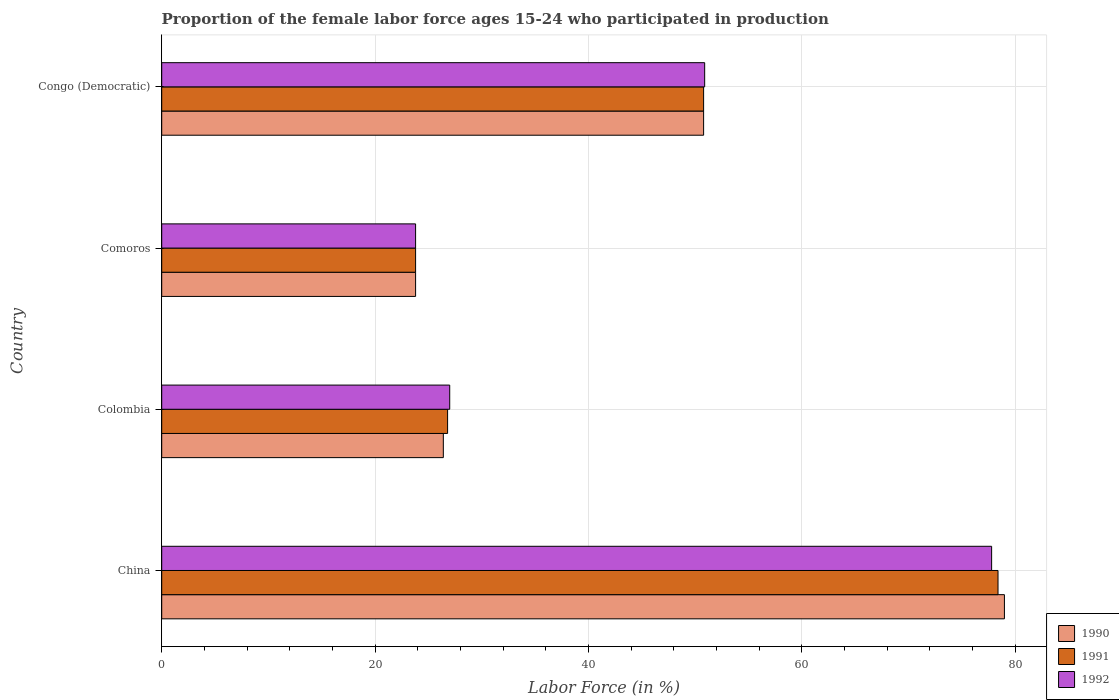Are the number of bars on each tick of the Y-axis equal?
Your answer should be very brief. Yes. How many bars are there on the 3rd tick from the bottom?
Provide a succinct answer. 3. What is the label of the 3rd group of bars from the top?
Provide a succinct answer. Colombia. In how many cases, is the number of bars for a given country not equal to the number of legend labels?
Offer a terse response. 0. What is the proportion of the female labor force who participated in production in 1991 in Congo (Democratic)?
Keep it short and to the point. 50.8. Across all countries, what is the maximum proportion of the female labor force who participated in production in 1991?
Ensure brevity in your answer.  78.4. Across all countries, what is the minimum proportion of the female labor force who participated in production in 1991?
Ensure brevity in your answer.  23.8. In which country was the proportion of the female labor force who participated in production in 1990 maximum?
Offer a very short reply. China. In which country was the proportion of the female labor force who participated in production in 1992 minimum?
Offer a terse response. Comoros. What is the total proportion of the female labor force who participated in production in 1990 in the graph?
Keep it short and to the point. 180. What is the difference between the proportion of the female labor force who participated in production in 1991 in Colombia and that in Congo (Democratic)?
Ensure brevity in your answer.  -24. What is the difference between the proportion of the female labor force who participated in production in 1992 in Comoros and the proportion of the female labor force who participated in production in 1990 in China?
Make the answer very short. -55.2. What is the average proportion of the female labor force who participated in production in 1990 per country?
Offer a terse response. 45. What is the difference between the proportion of the female labor force who participated in production in 1992 and proportion of the female labor force who participated in production in 1991 in Colombia?
Keep it short and to the point. 0.2. What is the ratio of the proportion of the female labor force who participated in production in 1990 in Colombia to that in Comoros?
Keep it short and to the point. 1.11. Is the difference between the proportion of the female labor force who participated in production in 1992 in Colombia and Congo (Democratic) greater than the difference between the proportion of the female labor force who participated in production in 1991 in Colombia and Congo (Democratic)?
Keep it short and to the point. Yes. What is the difference between the highest and the second highest proportion of the female labor force who participated in production in 1991?
Your answer should be compact. 27.6. What is the difference between the highest and the lowest proportion of the female labor force who participated in production in 1990?
Provide a succinct answer. 55.2. In how many countries, is the proportion of the female labor force who participated in production in 1992 greater than the average proportion of the female labor force who participated in production in 1992 taken over all countries?
Ensure brevity in your answer.  2. What does the 3rd bar from the bottom in Colombia represents?
Give a very brief answer. 1992. Is it the case that in every country, the sum of the proportion of the female labor force who participated in production in 1992 and proportion of the female labor force who participated in production in 1991 is greater than the proportion of the female labor force who participated in production in 1990?
Make the answer very short. Yes. How many bars are there?
Your answer should be very brief. 12. Are all the bars in the graph horizontal?
Make the answer very short. Yes. How many countries are there in the graph?
Give a very brief answer. 4. What is the difference between two consecutive major ticks on the X-axis?
Your answer should be compact. 20. Are the values on the major ticks of X-axis written in scientific E-notation?
Your answer should be compact. No. Does the graph contain any zero values?
Provide a short and direct response. No. Does the graph contain grids?
Keep it short and to the point. Yes. How are the legend labels stacked?
Make the answer very short. Vertical. What is the title of the graph?
Keep it short and to the point. Proportion of the female labor force ages 15-24 who participated in production. Does "1993" appear as one of the legend labels in the graph?
Keep it short and to the point. No. What is the label or title of the X-axis?
Offer a terse response. Labor Force (in %). What is the Labor Force (in %) of 1990 in China?
Ensure brevity in your answer.  79. What is the Labor Force (in %) in 1991 in China?
Your answer should be compact. 78.4. What is the Labor Force (in %) of 1992 in China?
Give a very brief answer. 77.8. What is the Labor Force (in %) of 1990 in Colombia?
Provide a short and direct response. 26.4. What is the Labor Force (in %) of 1991 in Colombia?
Ensure brevity in your answer.  26.8. What is the Labor Force (in %) of 1992 in Colombia?
Offer a terse response. 27. What is the Labor Force (in %) in 1990 in Comoros?
Provide a succinct answer. 23.8. What is the Labor Force (in %) in 1991 in Comoros?
Provide a short and direct response. 23.8. What is the Labor Force (in %) of 1992 in Comoros?
Make the answer very short. 23.8. What is the Labor Force (in %) of 1990 in Congo (Democratic)?
Your response must be concise. 50.8. What is the Labor Force (in %) in 1991 in Congo (Democratic)?
Offer a terse response. 50.8. What is the Labor Force (in %) of 1992 in Congo (Democratic)?
Give a very brief answer. 50.9. Across all countries, what is the maximum Labor Force (in %) of 1990?
Keep it short and to the point. 79. Across all countries, what is the maximum Labor Force (in %) of 1991?
Make the answer very short. 78.4. Across all countries, what is the maximum Labor Force (in %) in 1992?
Keep it short and to the point. 77.8. Across all countries, what is the minimum Labor Force (in %) of 1990?
Give a very brief answer. 23.8. Across all countries, what is the minimum Labor Force (in %) in 1991?
Your answer should be compact. 23.8. Across all countries, what is the minimum Labor Force (in %) of 1992?
Your answer should be very brief. 23.8. What is the total Labor Force (in %) of 1990 in the graph?
Keep it short and to the point. 180. What is the total Labor Force (in %) of 1991 in the graph?
Your response must be concise. 179.8. What is the total Labor Force (in %) of 1992 in the graph?
Your response must be concise. 179.5. What is the difference between the Labor Force (in %) of 1990 in China and that in Colombia?
Provide a short and direct response. 52.6. What is the difference between the Labor Force (in %) of 1991 in China and that in Colombia?
Ensure brevity in your answer.  51.6. What is the difference between the Labor Force (in %) in 1992 in China and that in Colombia?
Your answer should be compact. 50.8. What is the difference between the Labor Force (in %) in 1990 in China and that in Comoros?
Offer a terse response. 55.2. What is the difference between the Labor Force (in %) of 1991 in China and that in Comoros?
Keep it short and to the point. 54.6. What is the difference between the Labor Force (in %) of 1992 in China and that in Comoros?
Offer a terse response. 54. What is the difference between the Labor Force (in %) of 1990 in China and that in Congo (Democratic)?
Provide a succinct answer. 28.2. What is the difference between the Labor Force (in %) of 1991 in China and that in Congo (Democratic)?
Your response must be concise. 27.6. What is the difference between the Labor Force (in %) of 1992 in China and that in Congo (Democratic)?
Give a very brief answer. 26.9. What is the difference between the Labor Force (in %) of 1990 in Colombia and that in Comoros?
Keep it short and to the point. 2.6. What is the difference between the Labor Force (in %) of 1990 in Colombia and that in Congo (Democratic)?
Offer a very short reply. -24.4. What is the difference between the Labor Force (in %) in 1991 in Colombia and that in Congo (Democratic)?
Give a very brief answer. -24. What is the difference between the Labor Force (in %) in 1992 in Colombia and that in Congo (Democratic)?
Ensure brevity in your answer.  -23.9. What is the difference between the Labor Force (in %) of 1992 in Comoros and that in Congo (Democratic)?
Your response must be concise. -27.1. What is the difference between the Labor Force (in %) in 1990 in China and the Labor Force (in %) in 1991 in Colombia?
Ensure brevity in your answer.  52.2. What is the difference between the Labor Force (in %) in 1991 in China and the Labor Force (in %) in 1992 in Colombia?
Ensure brevity in your answer.  51.4. What is the difference between the Labor Force (in %) of 1990 in China and the Labor Force (in %) of 1991 in Comoros?
Offer a very short reply. 55.2. What is the difference between the Labor Force (in %) in 1990 in China and the Labor Force (in %) in 1992 in Comoros?
Your answer should be compact. 55.2. What is the difference between the Labor Force (in %) of 1991 in China and the Labor Force (in %) of 1992 in Comoros?
Offer a terse response. 54.6. What is the difference between the Labor Force (in %) in 1990 in China and the Labor Force (in %) in 1991 in Congo (Democratic)?
Your answer should be very brief. 28.2. What is the difference between the Labor Force (in %) in 1990 in China and the Labor Force (in %) in 1992 in Congo (Democratic)?
Make the answer very short. 28.1. What is the difference between the Labor Force (in %) in 1990 in Colombia and the Labor Force (in %) in 1992 in Comoros?
Ensure brevity in your answer.  2.6. What is the difference between the Labor Force (in %) in 1990 in Colombia and the Labor Force (in %) in 1991 in Congo (Democratic)?
Keep it short and to the point. -24.4. What is the difference between the Labor Force (in %) in 1990 in Colombia and the Labor Force (in %) in 1992 in Congo (Democratic)?
Make the answer very short. -24.5. What is the difference between the Labor Force (in %) of 1991 in Colombia and the Labor Force (in %) of 1992 in Congo (Democratic)?
Provide a succinct answer. -24.1. What is the difference between the Labor Force (in %) of 1990 in Comoros and the Labor Force (in %) of 1992 in Congo (Democratic)?
Your answer should be very brief. -27.1. What is the difference between the Labor Force (in %) in 1991 in Comoros and the Labor Force (in %) in 1992 in Congo (Democratic)?
Make the answer very short. -27.1. What is the average Labor Force (in %) of 1991 per country?
Offer a terse response. 44.95. What is the average Labor Force (in %) in 1992 per country?
Provide a short and direct response. 44.88. What is the difference between the Labor Force (in %) in 1991 and Labor Force (in %) in 1992 in China?
Give a very brief answer. 0.6. What is the difference between the Labor Force (in %) of 1990 and Labor Force (in %) of 1991 in Colombia?
Ensure brevity in your answer.  -0.4. What is the difference between the Labor Force (in %) in 1991 and Labor Force (in %) in 1992 in Colombia?
Provide a succinct answer. -0.2. What is the difference between the Labor Force (in %) of 1991 and Labor Force (in %) of 1992 in Congo (Democratic)?
Your answer should be very brief. -0.1. What is the ratio of the Labor Force (in %) in 1990 in China to that in Colombia?
Provide a succinct answer. 2.99. What is the ratio of the Labor Force (in %) of 1991 in China to that in Colombia?
Your answer should be very brief. 2.93. What is the ratio of the Labor Force (in %) of 1992 in China to that in Colombia?
Your answer should be very brief. 2.88. What is the ratio of the Labor Force (in %) of 1990 in China to that in Comoros?
Offer a very short reply. 3.32. What is the ratio of the Labor Force (in %) of 1991 in China to that in Comoros?
Your answer should be very brief. 3.29. What is the ratio of the Labor Force (in %) in 1992 in China to that in Comoros?
Keep it short and to the point. 3.27. What is the ratio of the Labor Force (in %) in 1990 in China to that in Congo (Democratic)?
Keep it short and to the point. 1.56. What is the ratio of the Labor Force (in %) in 1991 in China to that in Congo (Democratic)?
Your response must be concise. 1.54. What is the ratio of the Labor Force (in %) in 1992 in China to that in Congo (Democratic)?
Your response must be concise. 1.53. What is the ratio of the Labor Force (in %) in 1990 in Colombia to that in Comoros?
Provide a short and direct response. 1.11. What is the ratio of the Labor Force (in %) in 1991 in Colombia to that in Comoros?
Give a very brief answer. 1.13. What is the ratio of the Labor Force (in %) in 1992 in Colombia to that in Comoros?
Make the answer very short. 1.13. What is the ratio of the Labor Force (in %) of 1990 in Colombia to that in Congo (Democratic)?
Give a very brief answer. 0.52. What is the ratio of the Labor Force (in %) in 1991 in Colombia to that in Congo (Democratic)?
Offer a terse response. 0.53. What is the ratio of the Labor Force (in %) in 1992 in Colombia to that in Congo (Democratic)?
Provide a succinct answer. 0.53. What is the ratio of the Labor Force (in %) of 1990 in Comoros to that in Congo (Democratic)?
Your response must be concise. 0.47. What is the ratio of the Labor Force (in %) in 1991 in Comoros to that in Congo (Democratic)?
Offer a terse response. 0.47. What is the ratio of the Labor Force (in %) in 1992 in Comoros to that in Congo (Democratic)?
Keep it short and to the point. 0.47. What is the difference between the highest and the second highest Labor Force (in %) in 1990?
Ensure brevity in your answer.  28.2. What is the difference between the highest and the second highest Labor Force (in %) of 1991?
Give a very brief answer. 27.6. What is the difference between the highest and the second highest Labor Force (in %) of 1992?
Your answer should be very brief. 26.9. What is the difference between the highest and the lowest Labor Force (in %) in 1990?
Make the answer very short. 55.2. What is the difference between the highest and the lowest Labor Force (in %) of 1991?
Offer a very short reply. 54.6. What is the difference between the highest and the lowest Labor Force (in %) in 1992?
Offer a very short reply. 54. 